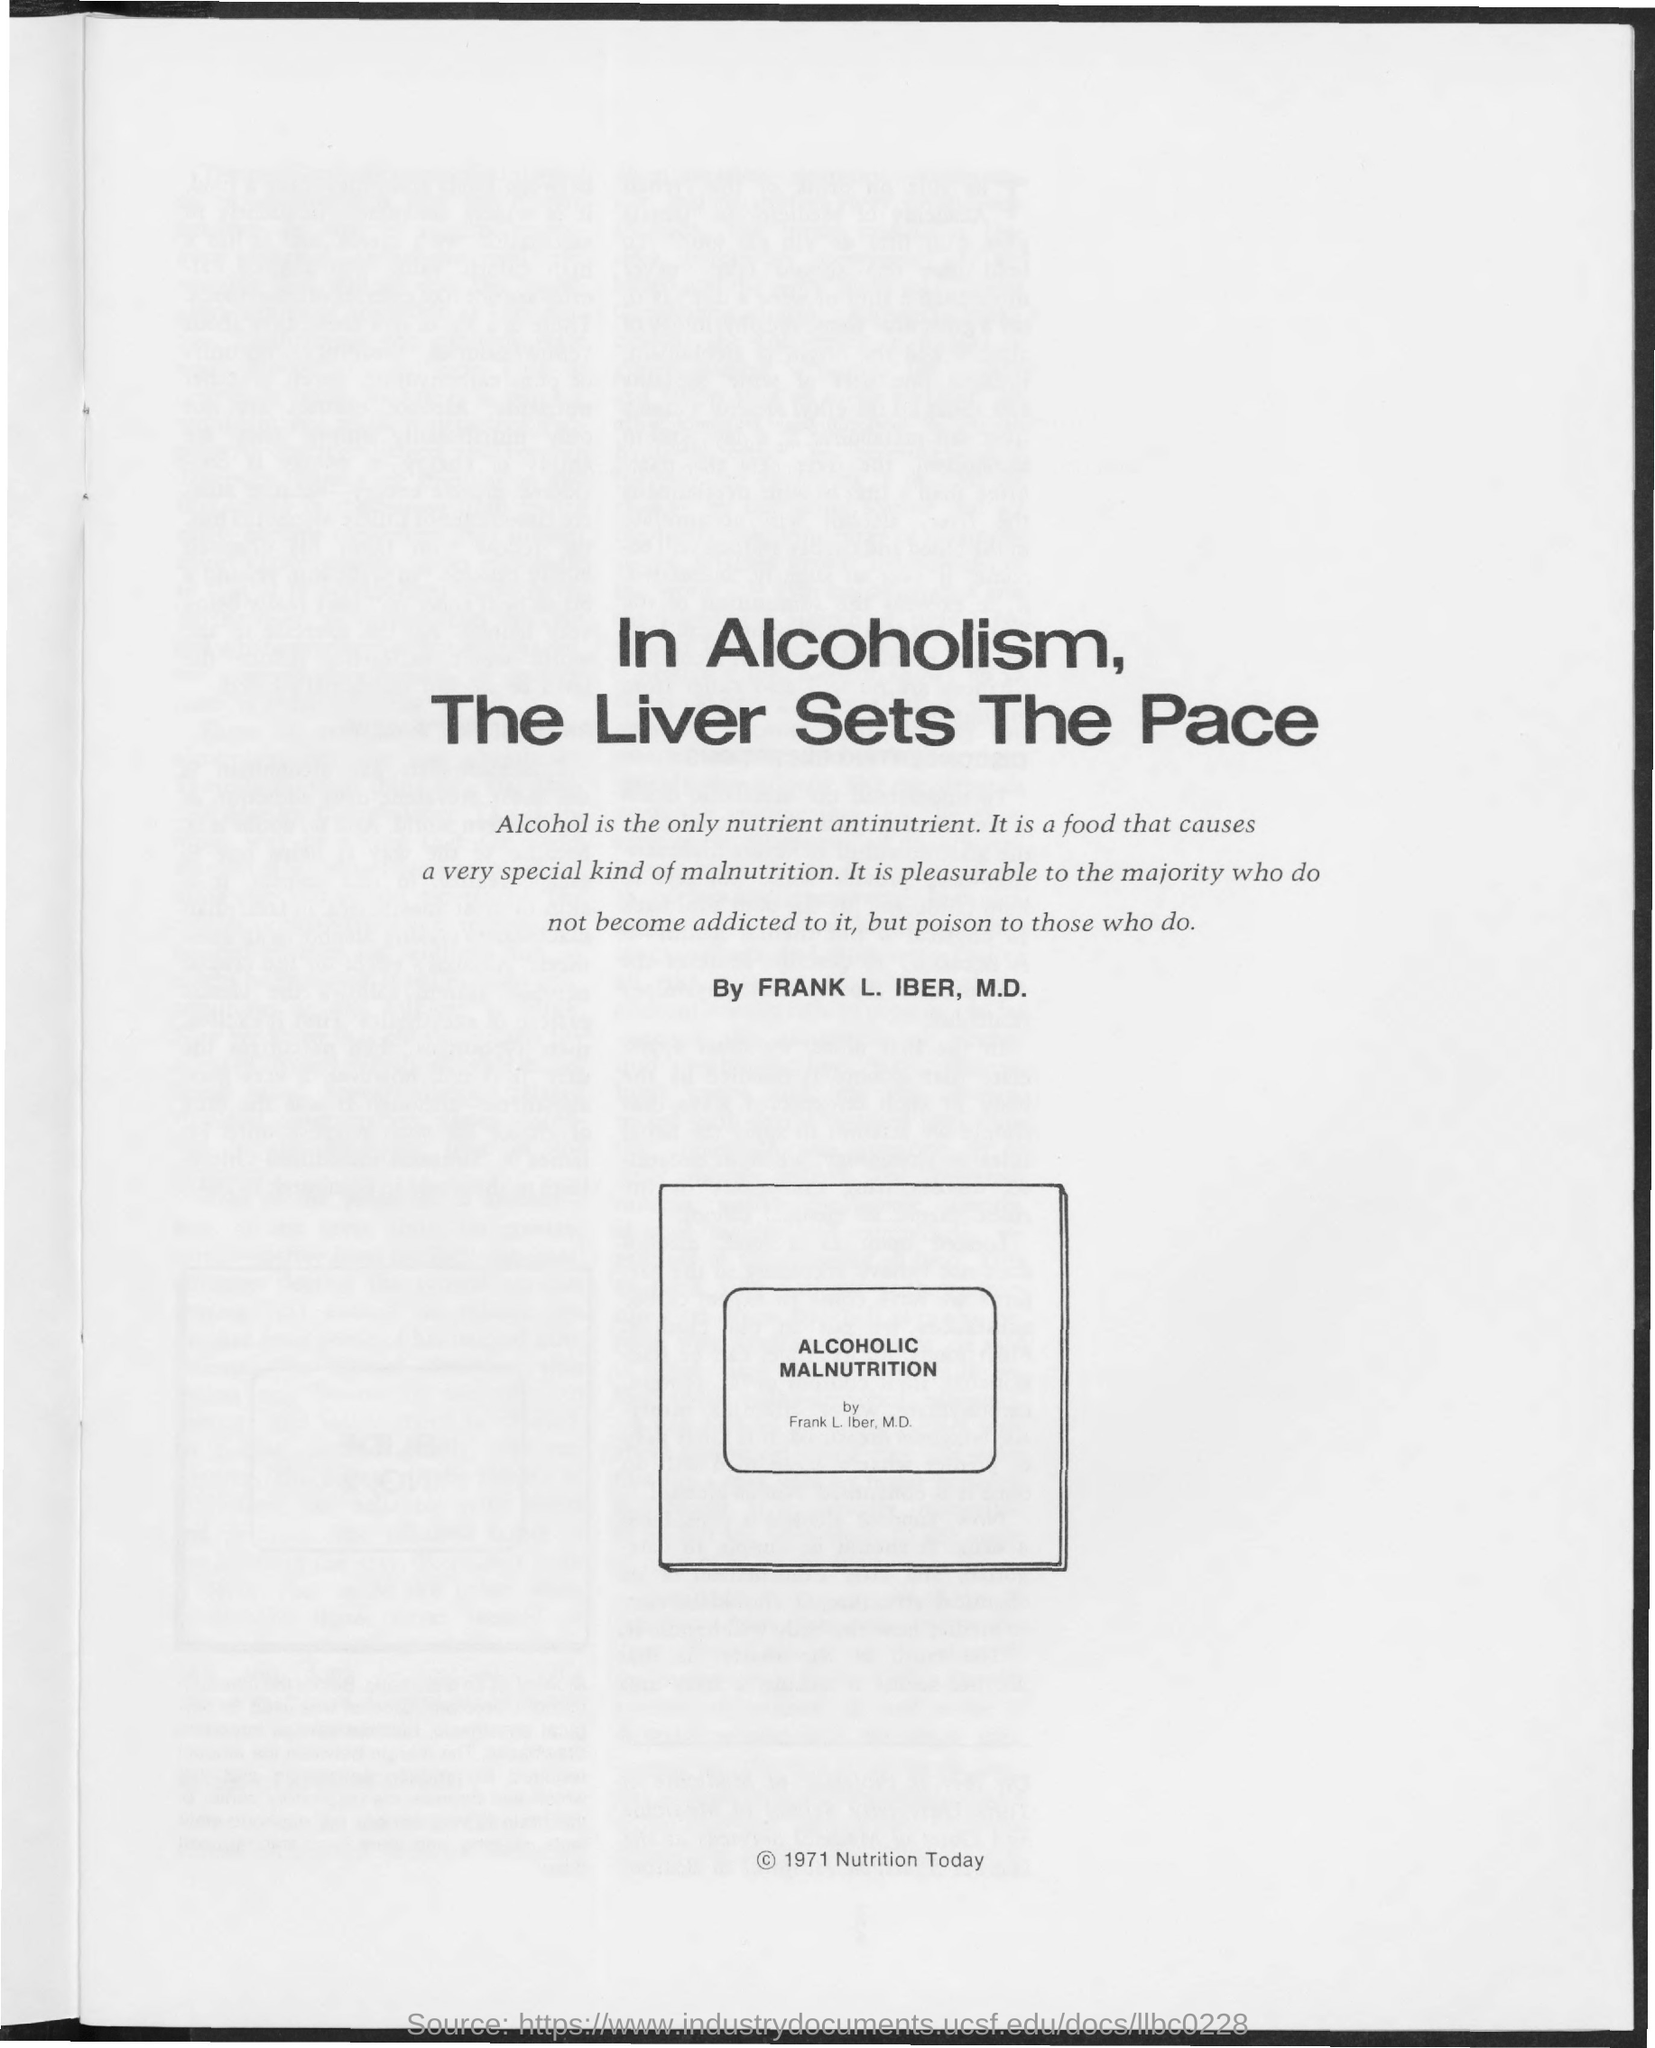List a handful of essential elements in this visual. Alcohol is the only nutrient antinutrient according to Frank L. Iber, M.D. 